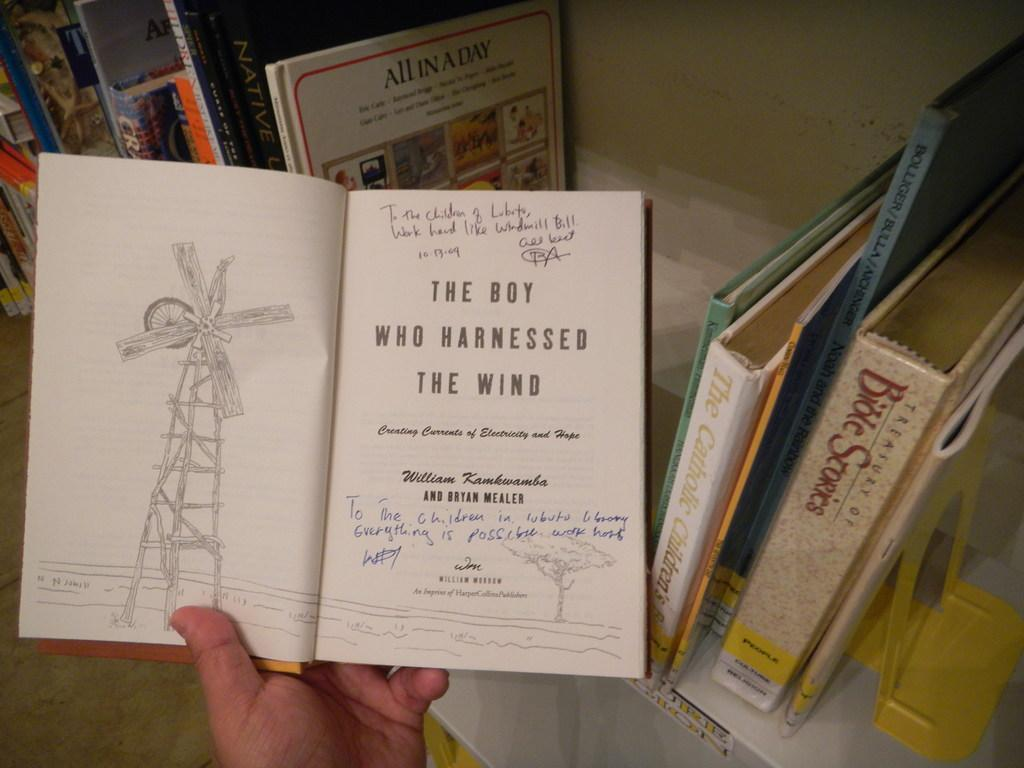<image>
Share a concise interpretation of the image provided. An open boook for the boy who harnessed the wind 